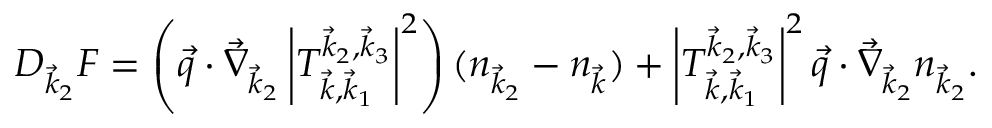<formula> <loc_0><loc_0><loc_500><loc_500>D _ { \vec { k } _ { 2 } } F = \left ( \vec { q } \cdot \vec { \nabla } _ { \vec { k } _ { 2 } } \left | T _ { \vec { k } , \vec { k } _ { 1 } } ^ { \vec { k } _ { 2 } , \vec { k } _ { 3 } } \right | ^ { 2 } \right ) ( n _ { \vec { k } _ { 2 } } - n _ { \vec { k } } ) + \left | T _ { \vec { k } , \vec { k } _ { 1 } } ^ { \vec { k } _ { 2 } , \vec { k } _ { 3 } } \right | ^ { 2 } \vec { q } \cdot \vec { \nabla } _ { \vec { k } _ { 2 } } n _ { \vec { k } _ { 2 } } .</formula> 